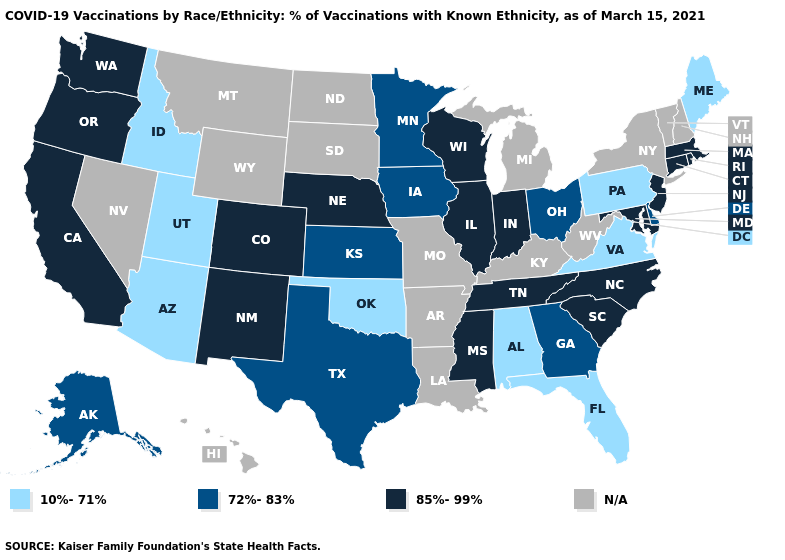What is the value of Iowa?
Short answer required. 72%-83%. Does the map have missing data?
Give a very brief answer. Yes. Which states have the lowest value in the USA?
Write a very short answer. Alabama, Arizona, Florida, Idaho, Maine, Oklahoma, Pennsylvania, Utah, Virginia. Which states have the lowest value in the USA?
Concise answer only. Alabama, Arizona, Florida, Idaho, Maine, Oklahoma, Pennsylvania, Utah, Virginia. What is the highest value in the USA?
Answer briefly. 85%-99%. Does Alabama have the lowest value in the USA?
Short answer required. Yes. How many symbols are there in the legend?
Keep it brief. 4. What is the highest value in the South ?
Short answer required. 85%-99%. What is the value of North Dakota?
Keep it brief. N/A. What is the value of Wisconsin?
Short answer required. 85%-99%. What is the value of Wisconsin?
Short answer required. 85%-99%. Is the legend a continuous bar?
Short answer required. No. Name the states that have a value in the range 72%-83%?
Concise answer only. Alaska, Delaware, Georgia, Iowa, Kansas, Minnesota, Ohio, Texas. What is the value of Alaska?
Be succinct. 72%-83%. 